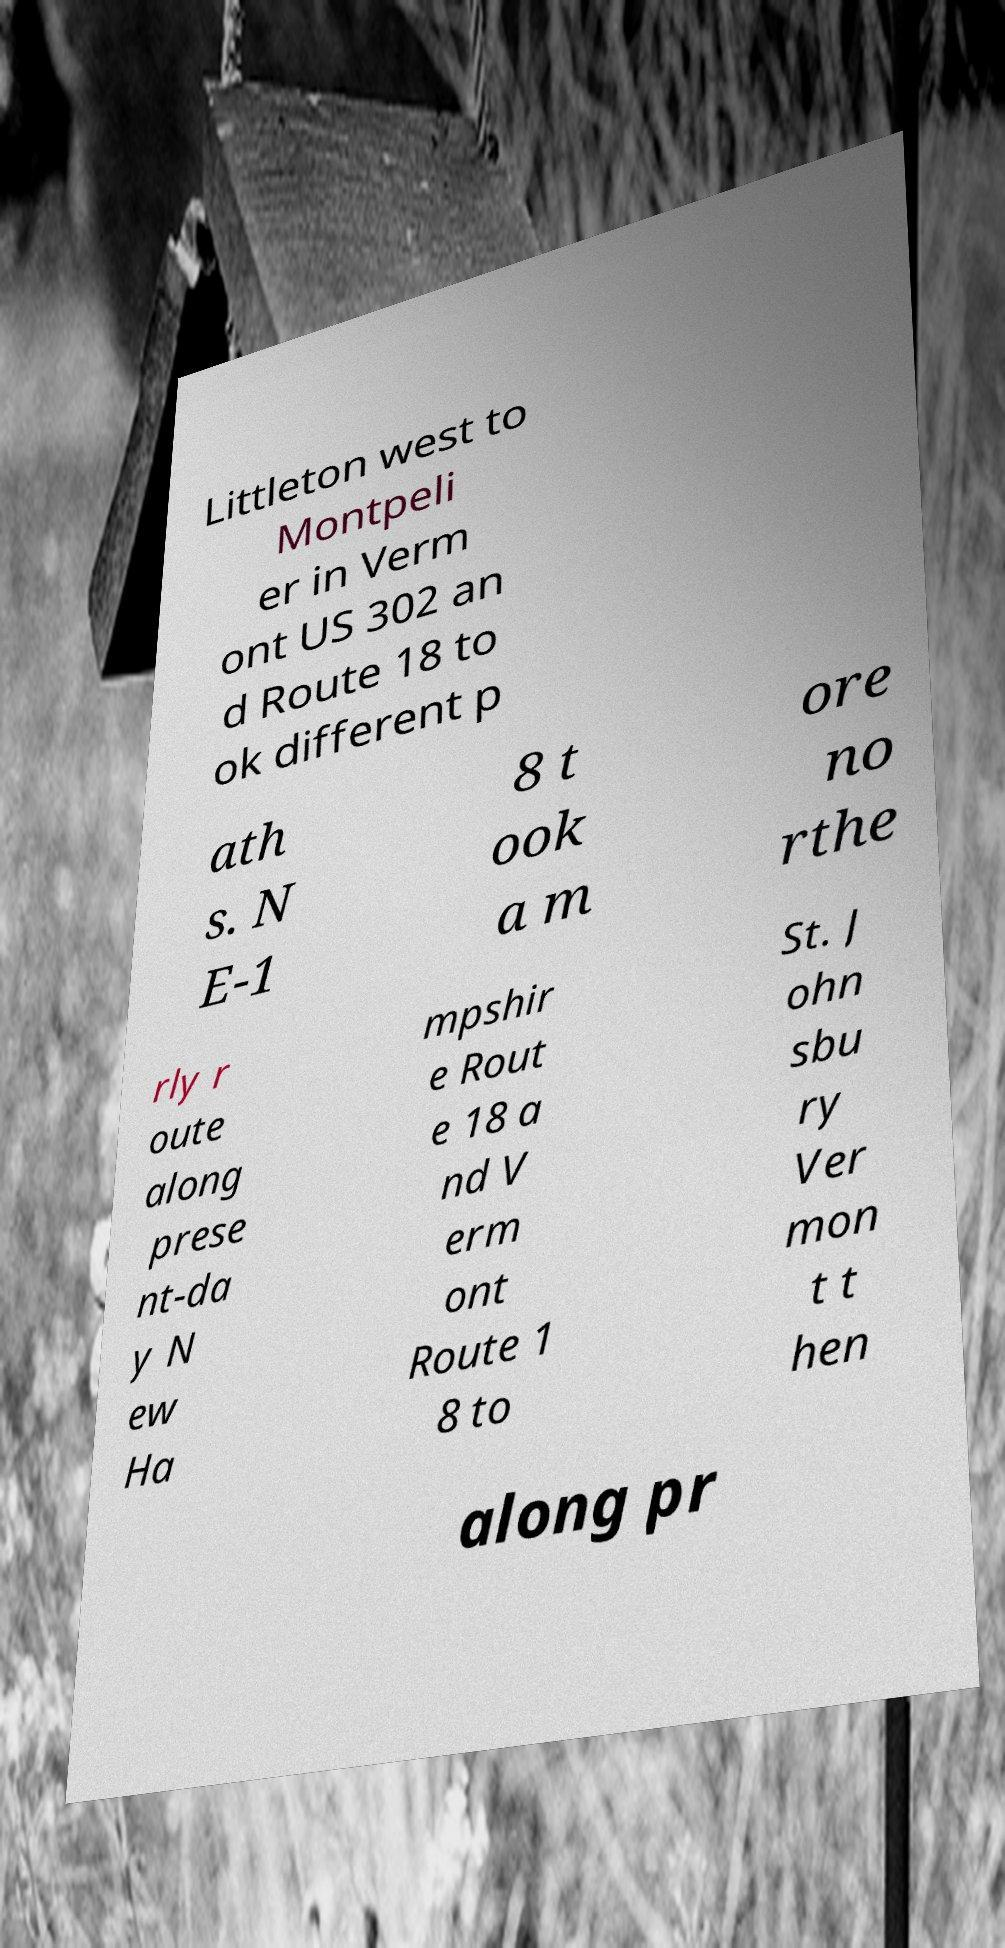Please read and relay the text visible in this image. What does it say? Littleton west to Montpeli er in Verm ont US 302 an d Route 18 to ok different p ath s. N E-1 8 t ook a m ore no rthe rly r oute along prese nt-da y N ew Ha mpshir e Rout e 18 a nd V erm ont Route 1 8 to St. J ohn sbu ry Ver mon t t hen along pr 